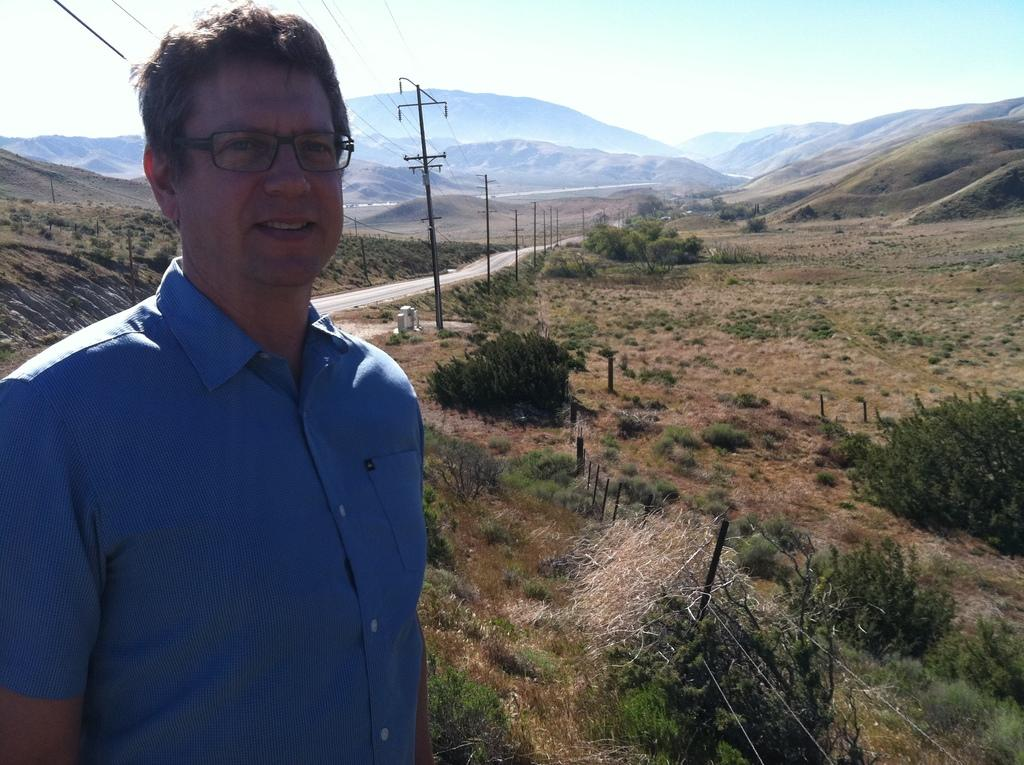What is the main subject of the image? There is a person in the image. Can you describe the person's appearance? The person is wearing glasses. What can be seen in the background of the image? There are hills, trees, poles with wires, and a road in the background of the image. What is visible at the top of the image? The sky is visible at the top of the image. What type of war is being fought in the image? There is no war present in the image; it features a person wearing glasses with a background of hills, trees, poles with wires, and a road. What part of the person's body is rolling in the image? There is no part of the person's body rolling in the image; they are standing still. 